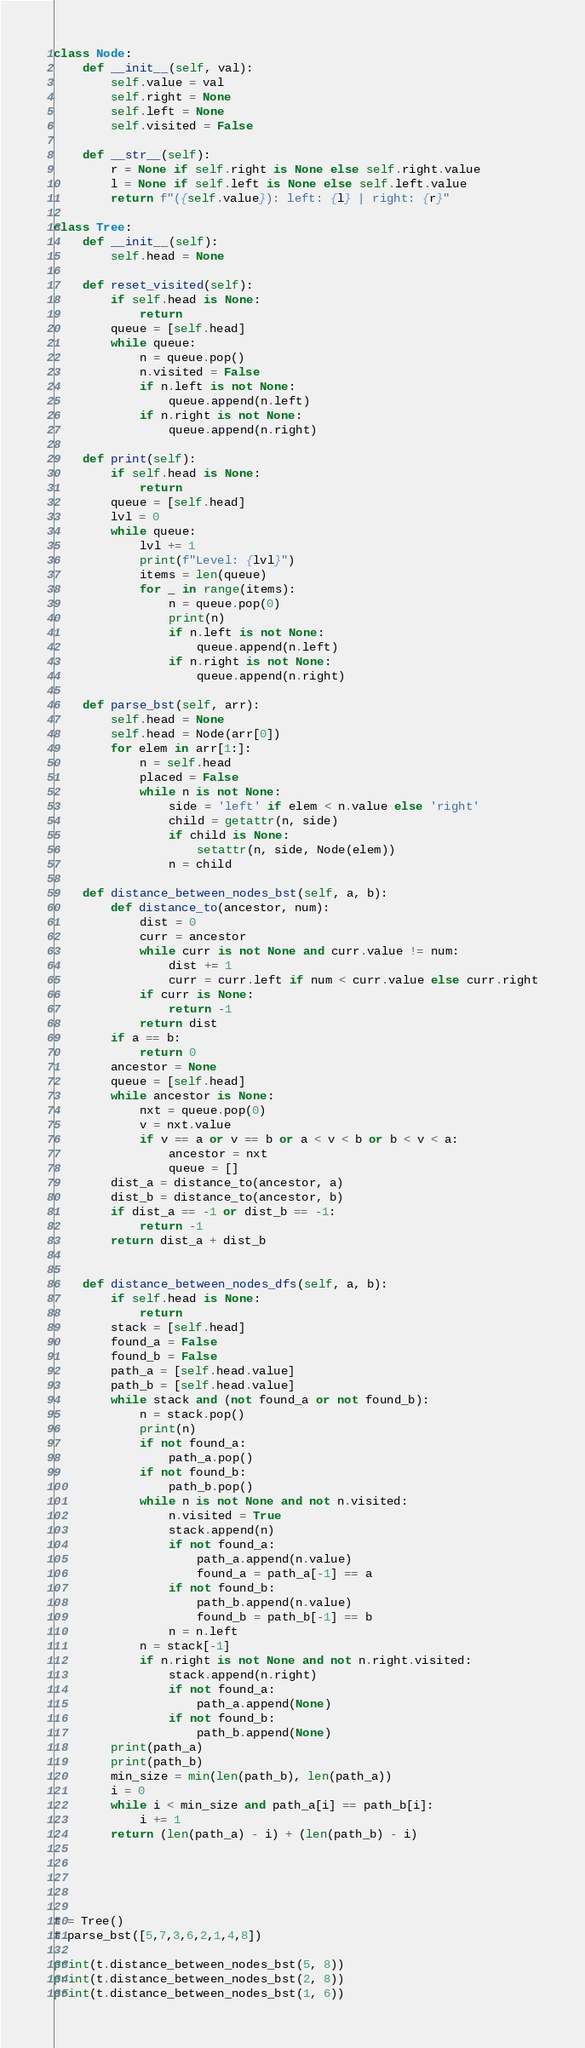Convert code to text. <code><loc_0><loc_0><loc_500><loc_500><_Python_>class Node:
    def __init__(self, val):
        self.value = val
        self.right = None
        self.left = None
        self.visited = False
    
    def __str__(self):
        r = None if self.right is None else self.right.value
        l = None if self.left is None else self.left.value
        return f"({self.value}): left: {l} | right: {r}"

class Tree:
    def __init__(self):
        self.head = None

    def reset_visited(self):
        if self.head is None:
            return
        queue = [self.head]
        while queue:
            n = queue.pop()
            n.visited = False
            if n.left is not None:
                queue.append(n.left)
            if n.right is not None:
                queue.append(n.right)
    
    def print(self):
        if self.head is None:
            return
        queue = [self.head]
        lvl = 0
        while queue:
            lvl += 1
            print(f"Level: {lvl}")
            items = len(queue)
            for _ in range(items):
                n = queue.pop(0)
                print(n)
                if n.left is not None:
                    queue.append(n.left)
                if n.right is not None:
                    queue.append(n.right)
    
    def parse_bst(self, arr):
        self.head = None
        self.head = Node(arr[0])
        for elem in arr[1:]:
            n = self.head
            placed = False
            while n is not None:
                side = 'left' if elem < n.value else 'right'
                child = getattr(n, side)
                if child is None:
                    setattr(n, side, Node(elem))
                n = child
    
    def distance_between_nodes_bst(self, a, b):
        def distance_to(ancestor, num):
            dist = 0
            curr = ancestor
            while curr is not None and curr.value != num:
                dist += 1
                curr = curr.left if num < curr.value else curr.right
            if curr is None:
                return -1
            return dist
        if a == b:
            return 0
        ancestor = None
        queue = [self.head]
        while ancestor is None:
            nxt = queue.pop(0)
            v = nxt.value
            if v == a or v == b or a < v < b or b < v < a:
                ancestor = nxt
                queue = []
        dist_a = distance_to(ancestor, a)
        dist_b = distance_to(ancestor, b)
        if dist_a == -1 or dist_b == -1:
            return -1
        return dist_a + dist_b
        

    def distance_between_nodes_dfs(self, a, b):
        if self.head is None:
            return
        stack = [self.head]
        found_a = False
        found_b = False
        path_a = [self.head.value]
        path_b = [self.head.value]
        while stack and (not found_a or not found_b):
            n = stack.pop()
            print(n)
            if not found_a:
                path_a.pop()
            if not found_b:
                path_b.pop()
            while n is not None and not n.visited:
                n.visited = True
                stack.append(n)
                if not found_a:
                    path_a.append(n.value)
                    found_a = path_a[-1] == a
                if not found_b:
                    path_b.append(n.value)
                    found_b = path_b[-1] == b
                n = n.left
            n = stack[-1]
            if n.right is not None and not n.right.visited:
                stack.append(n.right)
                if not found_a:
                    path_a.append(None)
                if not found_b:
                    path_b.append(None)
        print(path_a)
        print(path_b)
        min_size = min(len(path_b), len(path_a))
        i = 0
        while i < min_size and path_a[i] == path_b[i]:
            i += 1
        return (len(path_a) - i) + (len(path_b) - i)


                


t = Tree()
t.parse_bst([5,7,3,6,2,1,4,8])

print(t.distance_between_nodes_bst(5, 8))
print(t.distance_between_nodes_bst(2, 8))
print(t.distance_between_nodes_bst(1, 6))</code> 